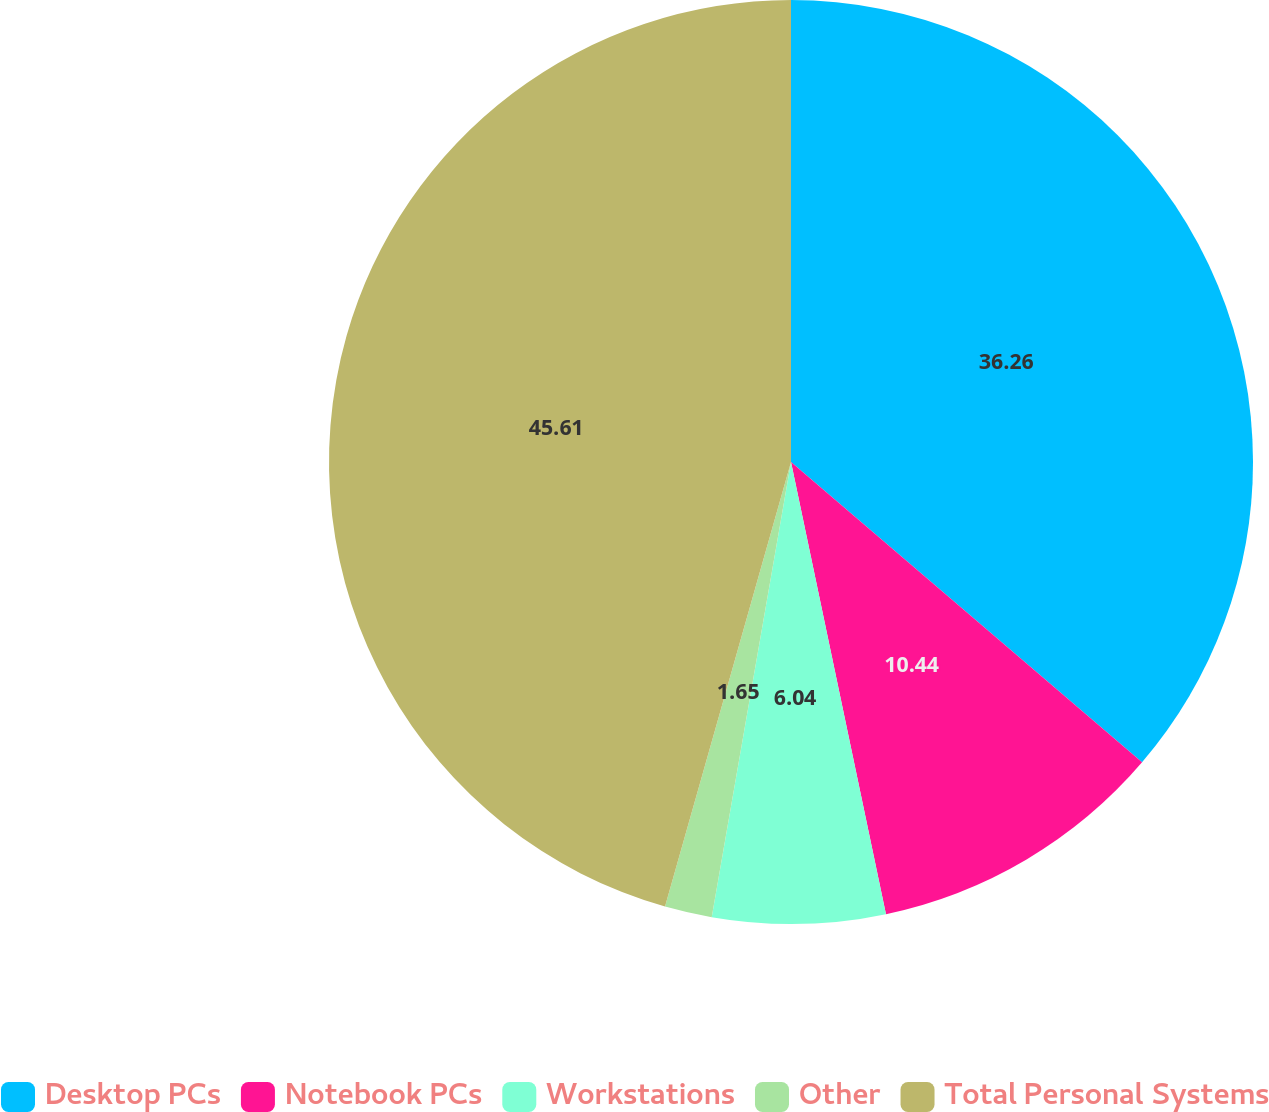<chart> <loc_0><loc_0><loc_500><loc_500><pie_chart><fcel>Desktop PCs<fcel>Notebook PCs<fcel>Workstations<fcel>Other<fcel>Total Personal Systems<nl><fcel>36.26%<fcel>10.44%<fcel>6.04%<fcel>1.65%<fcel>45.6%<nl></chart> 